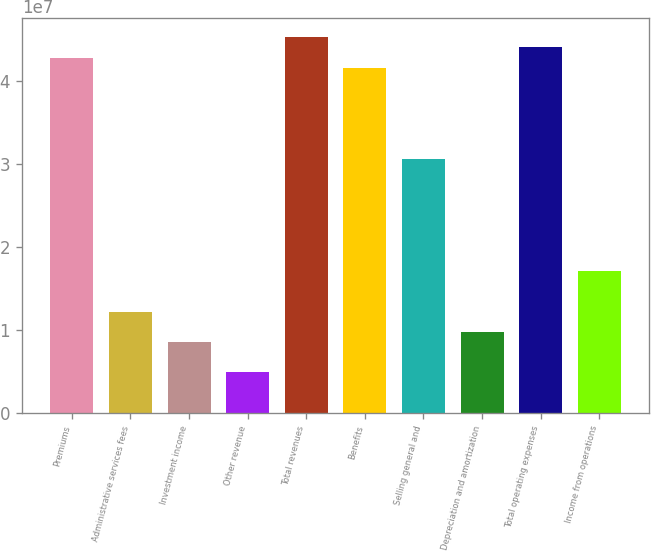Convert chart. <chart><loc_0><loc_0><loc_500><loc_500><bar_chart><fcel>Premiums<fcel>Administrative services fees<fcel>Investment income<fcel>Other revenue<fcel>Total revenues<fcel>Benefits<fcel>Selling general and<fcel>Depreciation and amortization<fcel>Total operating expenses<fcel>Income from operations<nl><fcel>4.27921e+07<fcel>1.22263e+07<fcel>8.55842e+06<fcel>4.89053e+06<fcel>4.52373e+07<fcel>4.15695e+07<fcel>3.05658e+07<fcel>9.78105e+06<fcel>4.40147e+07<fcel>1.71168e+07<nl></chart> 